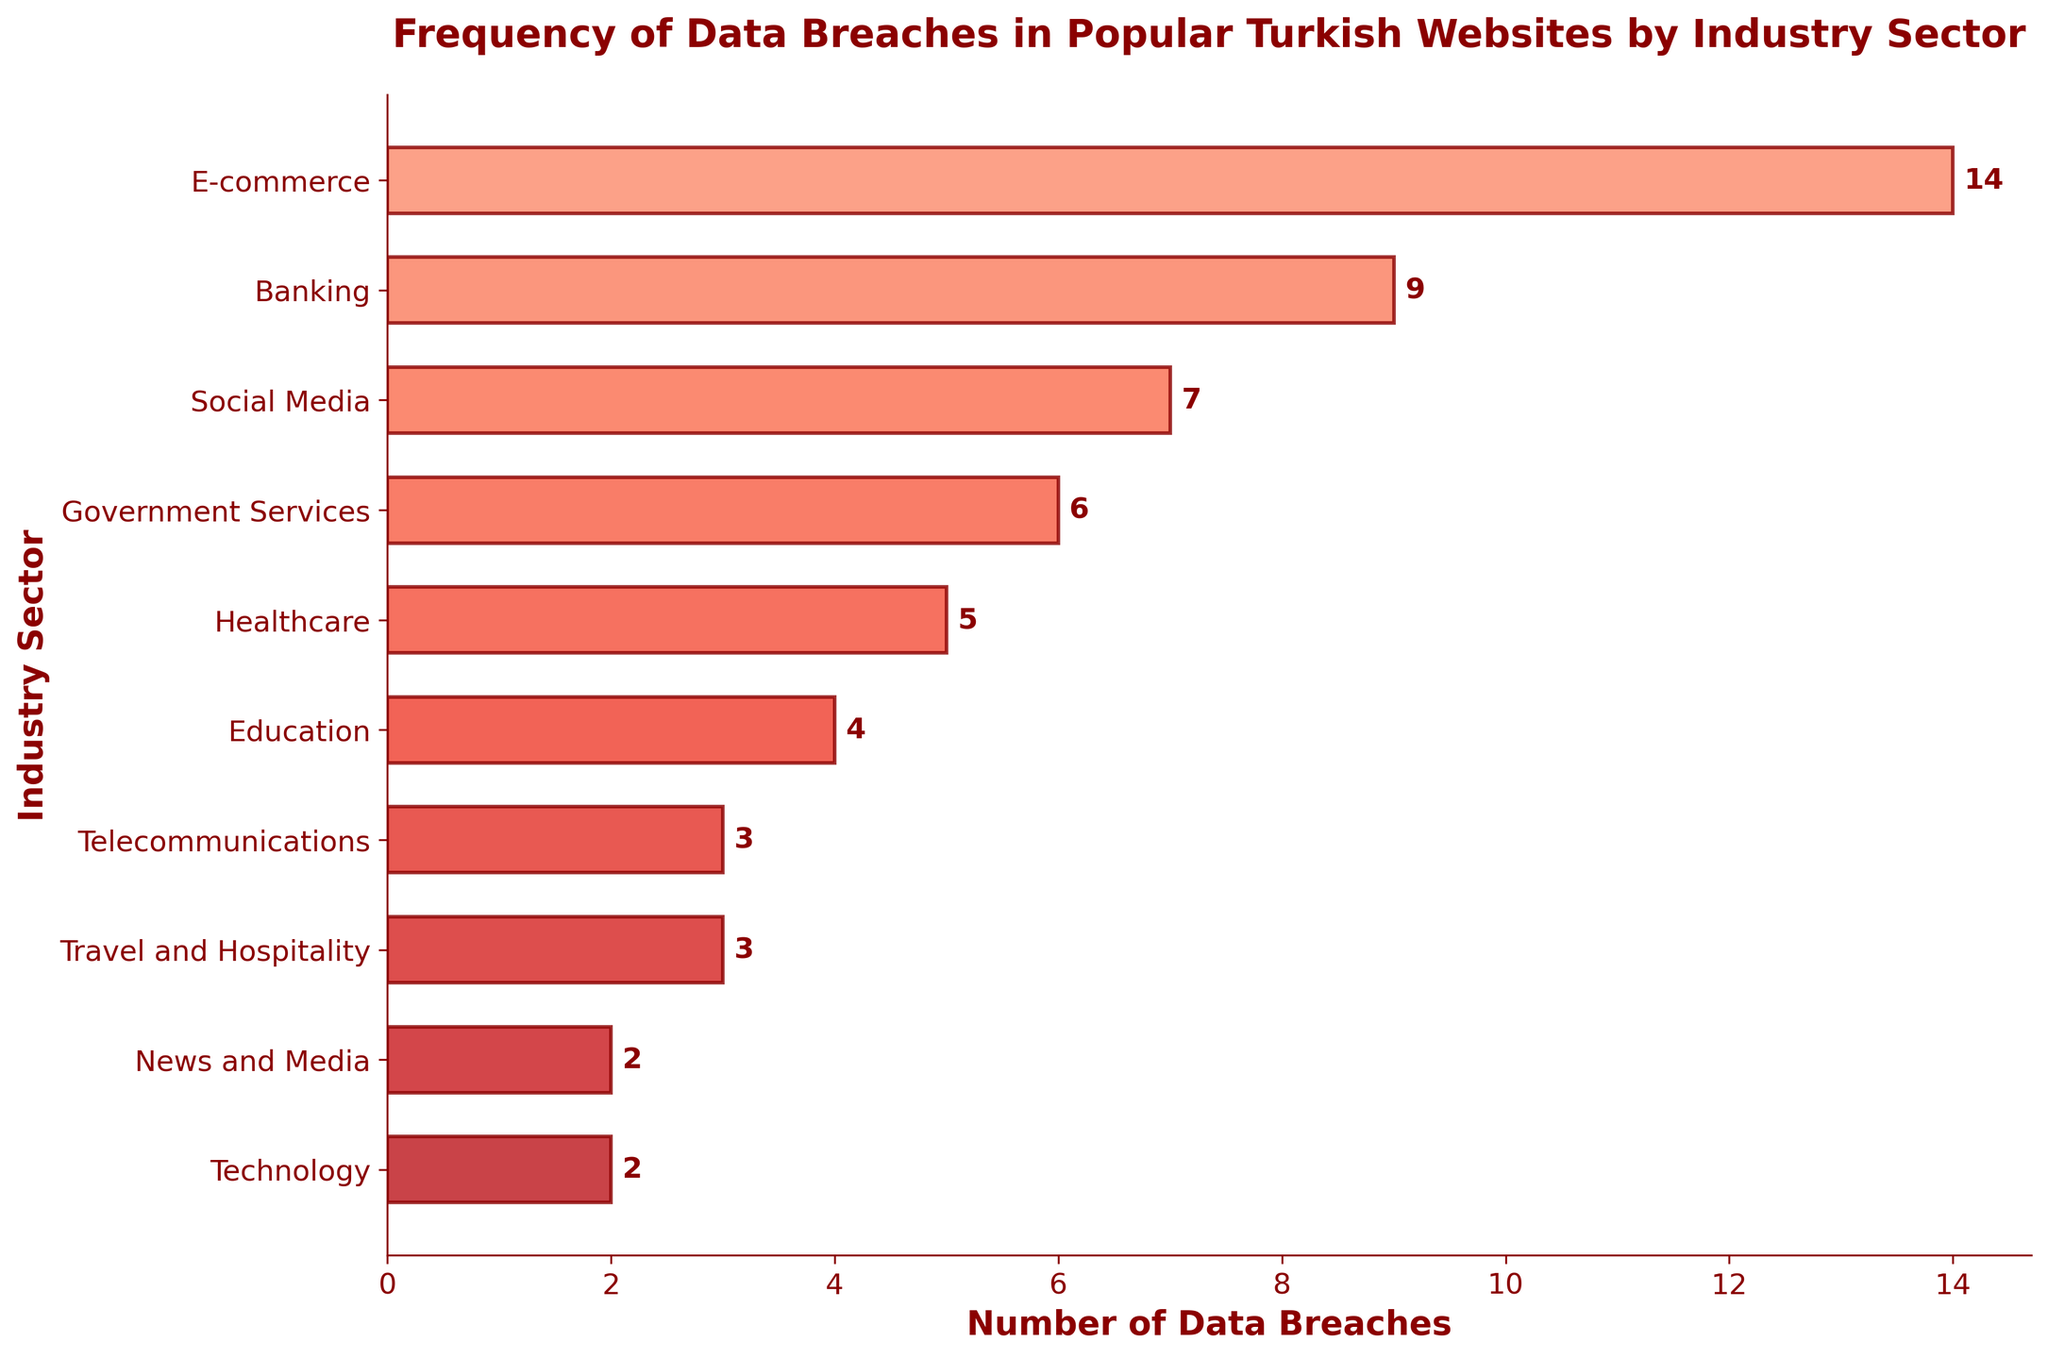Which industry sector has the most data breaches? The sector with the highest bar on the horizontal bar chart is "E-commerce", indicating it has the most data breaches.
Answer: E-commerce Which two sectors have an equal number of data breaches, and what is that number? By comparing the lengths of each bar, "Telecommunications" and "Travel and Hospitality" have equally long bars, representing 3 data breaches each.
Answer: Telecommunications and Travel and Hospitality, 3 breaches Which industry sector has the least data breaches? The sector with the shortest bar on the chart is "News and Media" and "Technology", each having the smallest number of data breaches.
Answer: News and Media and Technology How many more data breaches does the E-commerce sector have compared to the Government Services sector? The E-commerce sector has 14 breaches and Government Services has 6 breaches. Subtracting the latter from the former gives 14 - 6 = 8 more breaches.
Answer: 8 more breaches What is the total number of data breaches for the top three sectors combined? The top three sectors are E-commerce (14), Banking (9), and Social Media (7). Summing them up gives 14 + 9 + 7 = 30 total breaches.
Answer: 30 breaches Among the sectors with more than 5 data breaches, which one has the third-highest frequency? The sectors with more than 5 data breaches are E-commerce (14), Banking (9), Social Media (7), and Government Services (6). The third-highest is Social Media with 7 breaches.
Answer: Social Media How many sectors have fewer than 5 data breaches? Sectors with fewer than 5 breaches are Healthcare (5), Education (4), Telecommunications (3), Travel and Hospitality (3), News and Media (2), and Technology (2). Counting these gives us six sectors.
Answer: 6 sectors What is the average number of data breaches in sectors that have at least 7 breaches? The sectors with at least 7 breaches are E-commerce (14), Banking (9), and Social Media (7). The total breaches are 14 + 9 + 7 = 30, and the average is 30 / 3 = 10.
Answer: 10 breaches 